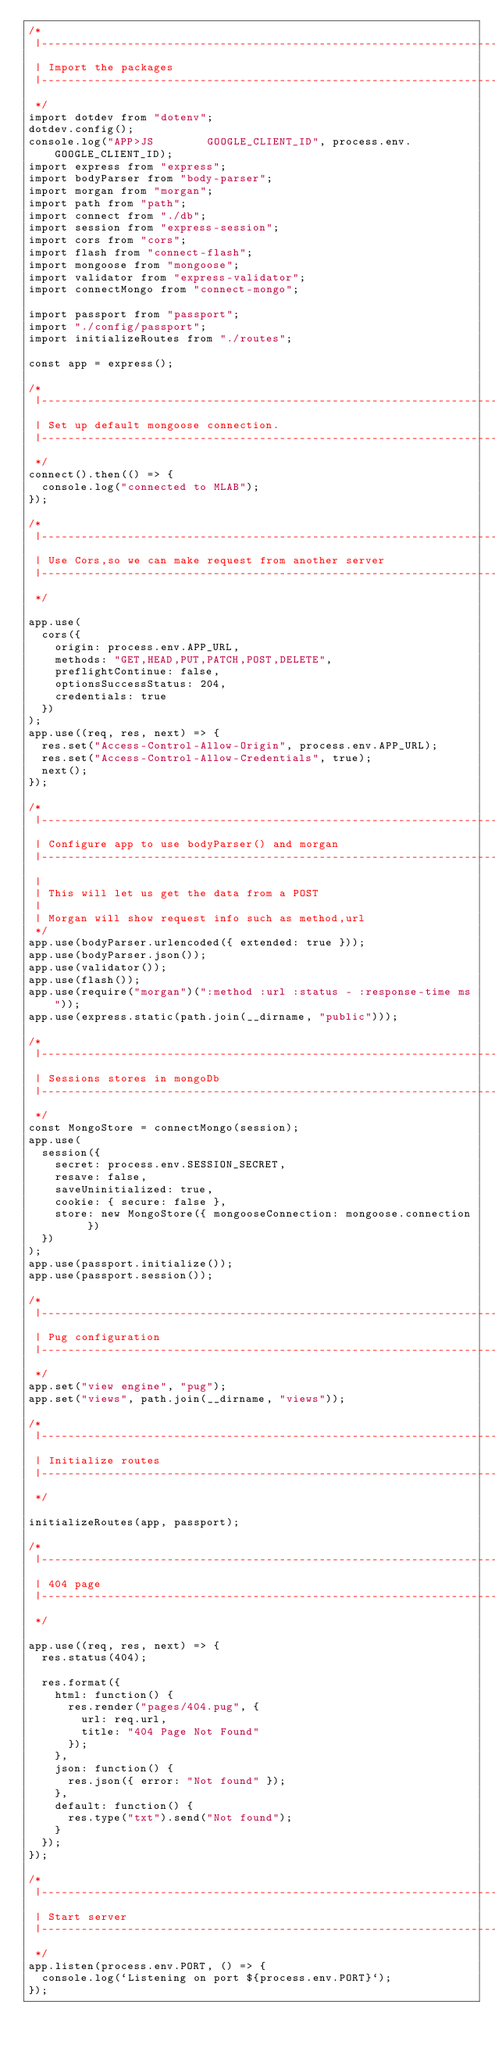Convert code to text. <code><loc_0><loc_0><loc_500><loc_500><_JavaScript_>/*
 |--------------------------------------------------------------------------
 | Import the packages
 |--------------------------------------------------------------------------
 */
import dotdev from "dotenv";
dotdev.config();
console.log("APP>JS        GOOGLE_CLIENT_ID", process.env.GOOGLE_CLIENT_ID);
import express from "express";
import bodyParser from "body-parser";
import morgan from "morgan";
import path from "path";
import connect from "./db";
import session from "express-session";
import cors from "cors";
import flash from "connect-flash";
import mongoose from "mongoose";
import validator from "express-validator";
import connectMongo from "connect-mongo";

import passport from "passport";
import "./config/passport";
import initializeRoutes from "./routes";

const app = express();

/*
 |--------------------------------------------------------------------------
 | Set up default mongoose connection.
 |--------------------------------------------------------------------------
 */
connect().then(() => {
  console.log("connected to MLAB");
});

/*
 |--------------------------------------------------------------------------
 | Use Cors,so we can make request from another server
 |--------------------------------------------------------------------------
 */

app.use(
  cors({
    origin: process.env.APP_URL,
    methods: "GET,HEAD,PUT,PATCH,POST,DELETE",
    preflightContinue: false,
    optionsSuccessStatus: 204,
    credentials: true
  })
);
app.use((req, res, next) => {
  res.set("Access-Control-Allow-Origin", process.env.APP_URL);
  res.set("Access-Control-Allow-Credentials", true);
  next();
});

/*
 |--------------------------------------------------------------------------
 | Configure app to use bodyParser() and morgan
 |--------------------------------------------------------------------------
 |
 | This will let us get the data from a POST
 |
 | Morgan will show request info such as method,url
 */
app.use(bodyParser.urlencoded({ extended: true }));
app.use(bodyParser.json());
app.use(validator());
app.use(flash());
app.use(require("morgan")(":method :url :status - :response-time ms"));
app.use(express.static(path.join(__dirname, "public")));

/*
 |--------------------------------------------------------------------------
 | Sessions stores in mongoDb
 |--------------------------------------------------------------------------
 */
const MongoStore = connectMongo(session);
app.use(
  session({
    secret: process.env.SESSION_SECRET,
    resave: false,
    saveUninitialized: true,
    cookie: { secure: false },
    store: new MongoStore({ mongooseConnection: mongoose.connection })
  })
);
app.use(passport.initialize());
app.use(passport.session());

/*
 |--------------------------------------------------------------------------
 | Pug configuration
 |--------------------------------------------------------------------------
 */
app.set("view engine", "pug");
app.set("views", path.join(__dirname, "views"));

/*
 |--------------------------------------------------------------------------
 | Initialize routes
 |--------------------------------------------------------------------------
 */

initializeRoutes(app, passport);

/*
 |--------------------------------------------------------------------------
 | 404 page
 |--------------------------------------------------------------------------
 */

app.use((req, res, next) => {
  res.status(404);

  res.format({
    html: function() {
      res.render("pages/404.pug", {
        url: req.url,
        title: "404 Page Not Found"
      });
    },
    json: function() {
      res.json({ error: "Not found" });
    },
    default: function() {
      res.type("txt").send("Not found");
    }
  });
});

/*
 |--------------------------------------------------------------------------
 | Start server
 |--------------------------------------------------------------------------
 */
app.listen(process.env.PORT, () => {
  console.log(`Listening on port ${process.env.PORT}`);
});
</code> 